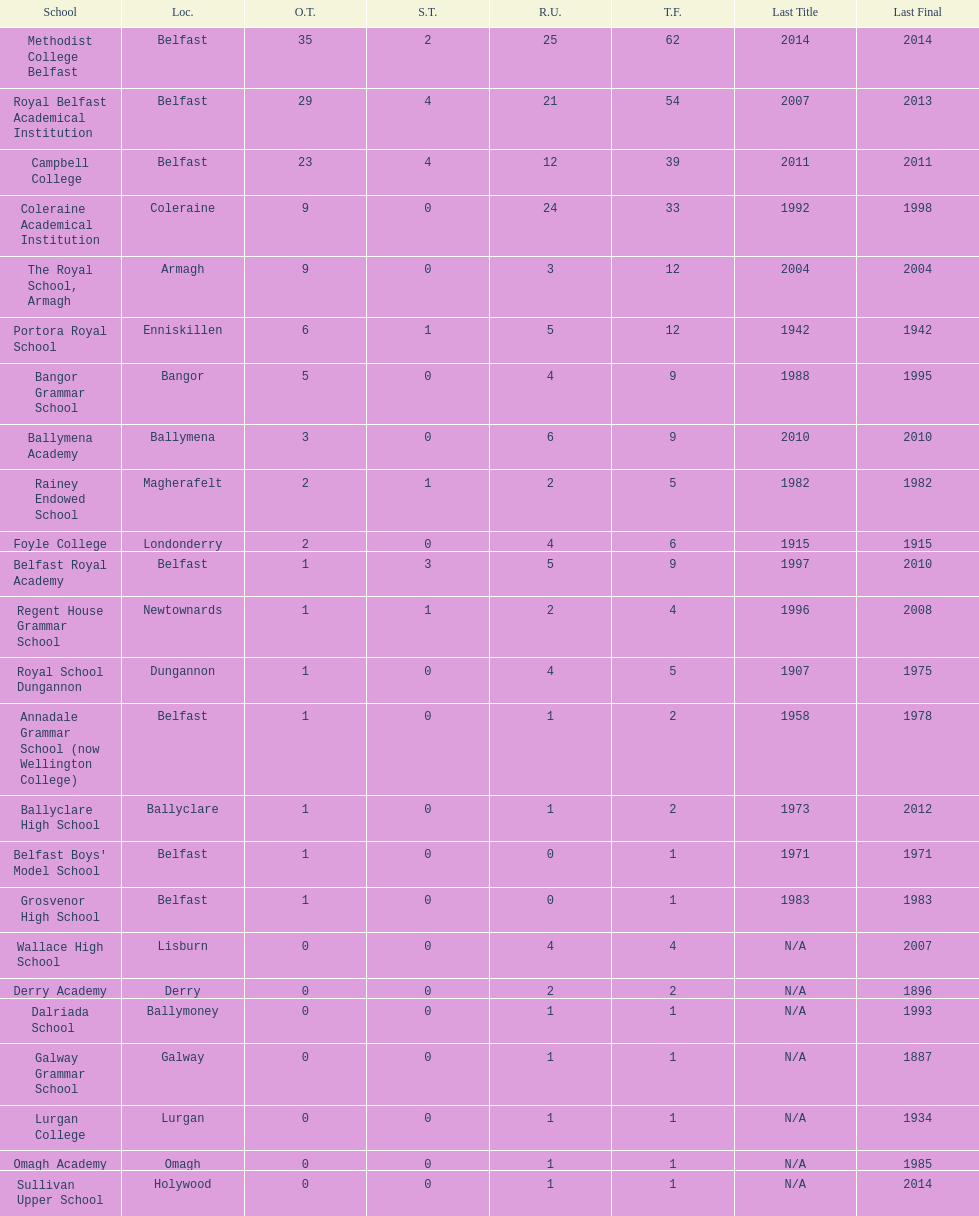How many schools have at least 5 outright titles? 7. 